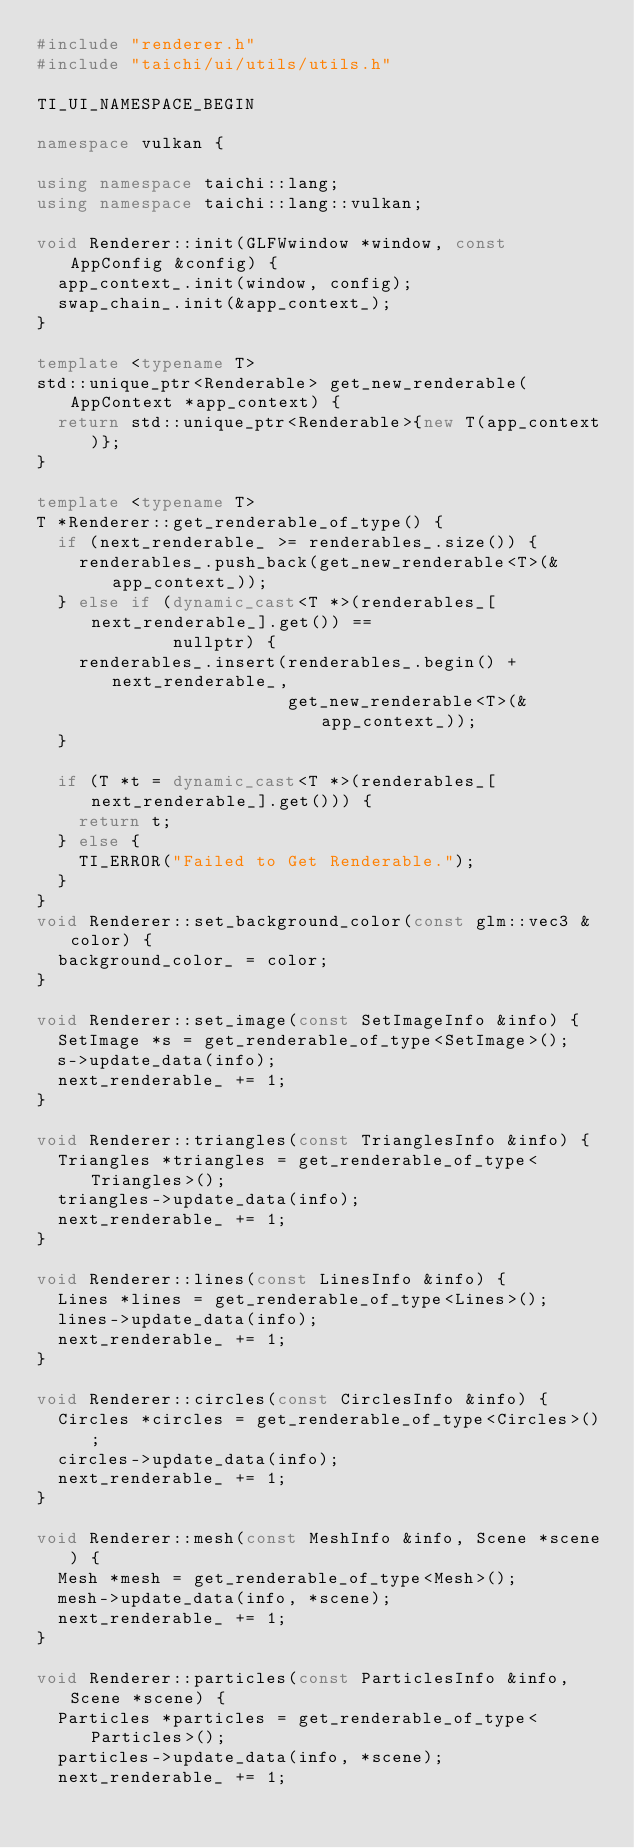<code> <loc_0><loc_0><loc_500><loc_500><_C++_>#include "renderer.h"
#include "taichi/ui/utils/utils.h"

TI_UI_NAMESPACE_BEGIN

namespace vulkan {

using namespace taichi::lang;
using namespace taichi::lang::vulkan;

void Renderer::init(GLFWwindow *window, const AppConfig &config) {
  app_context_.init(window, config);
  swap_chain_.init(&app_context_);
}

template <typename T>
std::unique_ptr<Renderable> get_new_renderable(AppContext *app_context) {
  return std::unique_ptr<Renderable>{new T(app_context)};
}

template <typename T>
T *Renderer::get_renderable_of_type() {
  if (next_renderable_ >= renderables_.size()) {
    renderables_.push_back(get_new_renderable<T>(&app_context_));
  } else if (dynamic_cast<T *>(renderables_[next_renderable_].get()) ==
             nullptr) {
    renderables_.insert(renderables_.begin() + next_renderable_,
                        get_new_renderable<T>(&app_context_));
  }

  if (T *t = dynamic_cast<T *>(renderables_[next_renderable_].get())) {
    return t;
  } else {
    TI_ERROR("Failed to Get Renderable.");
  }
}
void Renderer::set_background_color(const glm::vec3 &color) {
  background_color_ = color;
}

void Renderer::set_image(const SetImageInfo &info) {
  SetImage *s = get_renderable_of_type<SetImage>();
  s->update_data(info);
  next_renderable_ += 1;
}

void Renderer::triangles(const TrianglesInfo &info) {
  Triangles *triangles = get_renderable_of_type<Triangles>();
  triangles->update_data(info);
  next_renderable_ += 1;
}

void Renderer::lines(const LinesInfo &info) {
  Lines *lines = get_renderable_of_type<Lines>();
  lines->update_data(info);
  next_renderable_ += 1;
}

void Renderer::circles(const CirclesInfo &info) {
  Circles *circles = get_renderable_of_type<Circles>();
  circles->update_data(info);
  next_renderable_ += 1;
}

void Renderer::mesh(const MeshInfo &info, Scene *scene) {
  Mesh *mesh = get_renderable_of_type<Mesh>();
  mesh->update_data(info, *scene);
  next_renderable_ += 1;
}

void Renderer::particles(const ParticlesInfo &info, Scene *scene) {
  Particles *particles = get_renderable_of_type<Particles>();
  particles->update_data(info, *scene);
  next_renderable_ += 1;</code> 